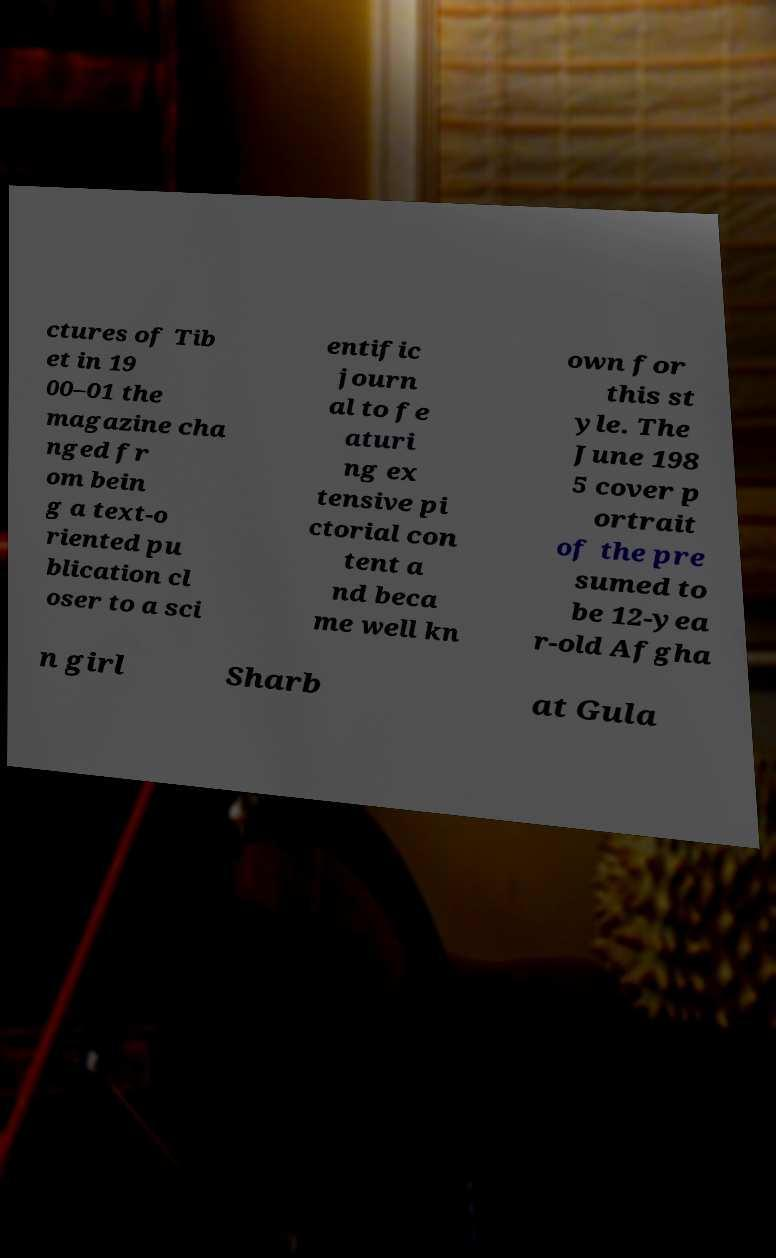Please identify and transcribe the text found in this image. ctures of Tib et in 19 00–01 the magazine cha nged fr om bein g a text-o riented pu blication cl oser to a sci entific journ al to fe aturi ng ex tensive pi ctorial con tent a nd beca me well kn own for this st yle. The June 198 5 cover p ortrait of the pre sumed to be 12-yea r-old Afgha n girl Sharb at Gula 